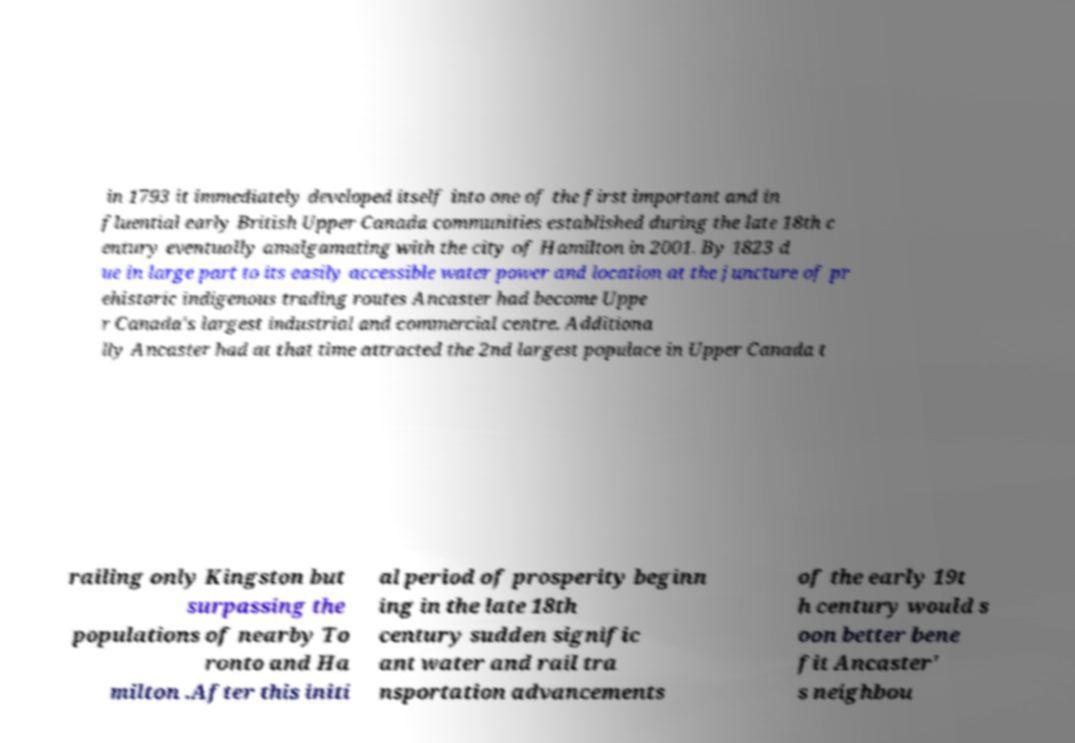For documentation purposes, I need the text within this image transcribed. Could you provide that? in 1793 it immediately developed itself into one of the first important and in fluential early British Upper Canada communities established during the late 18th c entury eventually amalgamating with the city of Hamilton in 2001. By 1823 d ue in large part to its easily accessible water power and location at the juncture of pr ehistoric indigenous trading routes Ancaster had become Uppe r Canada's largest industrial and commercial centre. Additiona lly Ancaster had at that time attracted the 2nd largest populace in Upper Canada t railing only Kingston but surpassing the populations of nearby To ronto and Ha milton .After this initi al period of prosperity beginn ing in the late 18th century sudden signific ant water and rail tra nsportation advancements of the early 19t h century would s oon better bene fit Ancaster' s neighbou 